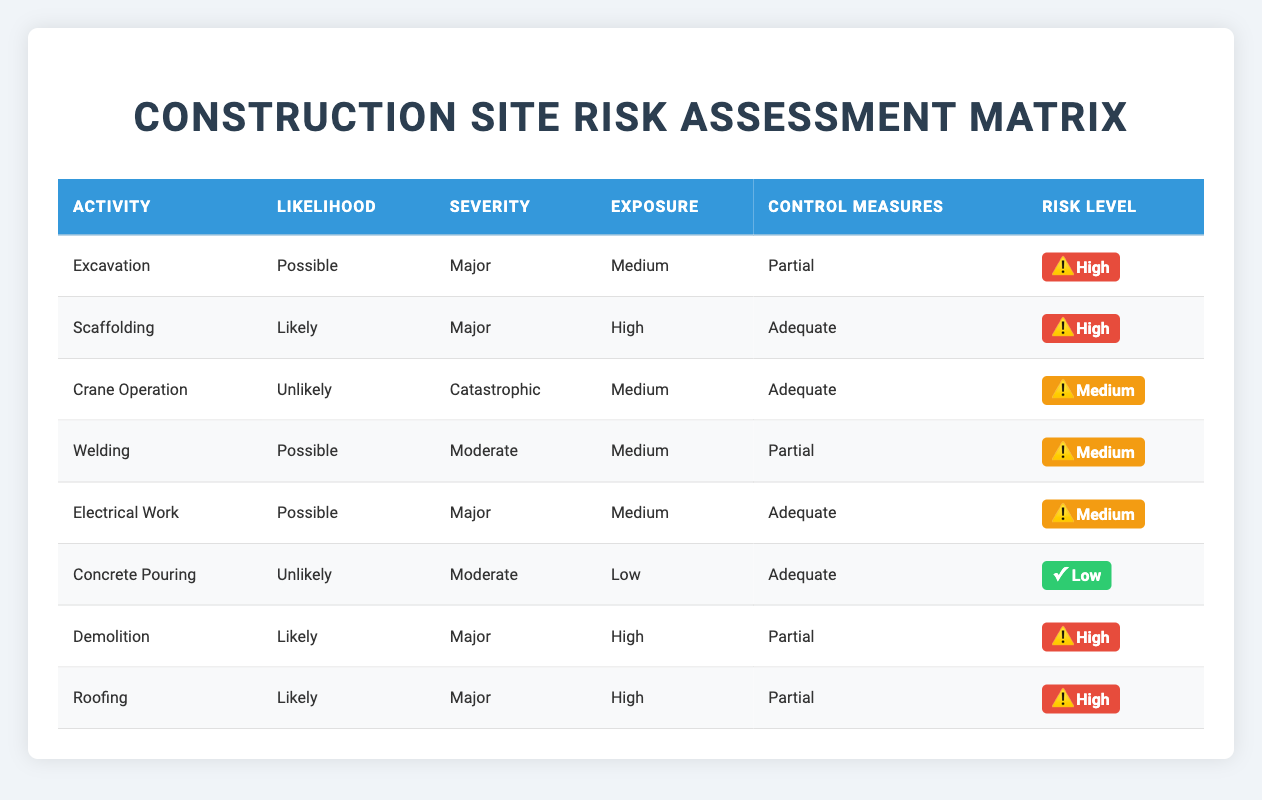What is the likelihood associated with Excavation? The likelihood for Excavation is listed directly under the "Likelihood" column in the row for Excavation, and it states "Possible".
Answer: Possible Which activity has the highest exposure level? To find the highest exposure level, we look at the "Exposure" column. The "High" exposure level appears in the rows for Scaffolding, Demolition, and Roofing. Therefore, these activities share the highest exposure level.
Answer: Scaffolding, Demolition, and Roofing Is the control measure for Crane Operation adequate? The control measure for Crane Operation can be found in the "Control Measures" column for that activity. It states "Adequate", confirming that the control measures in place are acceptable.
Answer: Yes How many activities have a Major severity level? To determine how many activities are classified with a Major severity level, we count the occurrences of "Major" in the "Severity" column. This occurs for Excavation, Scaffolding, Electrical Work, Demolition, and Roofing, totaling five activities.
Answer: 5 What is the exposure level for Welding compared to Excavation? Welding has a "Medium" exposure level while Excavation has a "Medium" exposure level as well. We compare the two directly, and since both are the same, they have equivalent exposure.
Answer: They are the same (Medium) Which activity has the lowest overall risk? The overall risk can be inferred from the combination of likelihood, severity, exposure, and control measures. Concrete Pouring stands out as it has "Unlikely" likelihood, "Moderate" severity, "Low" exposure, and "Adequate" control measures, indicating the lowest risk among the activities listed.
Answer: Concrete Pouring Are all activities with a Likelihood of Likely rated High risk? We check the activities with "Likely" under the "Likelihood" column, which are Scaffolding, Demolition, and Roofing. All these activities also have "Major" severity and "High" exposure, confirming they are all rated High risk.
Answer: Yes Which activity has the highest severity rating and what is it? The highest severity rating is "Catastrophic," which is observed for Crane Operation in the "Severity" column. This indicates it is the most severe risk in this assessment.
Answer: Catastrophic (Crane Operation) 